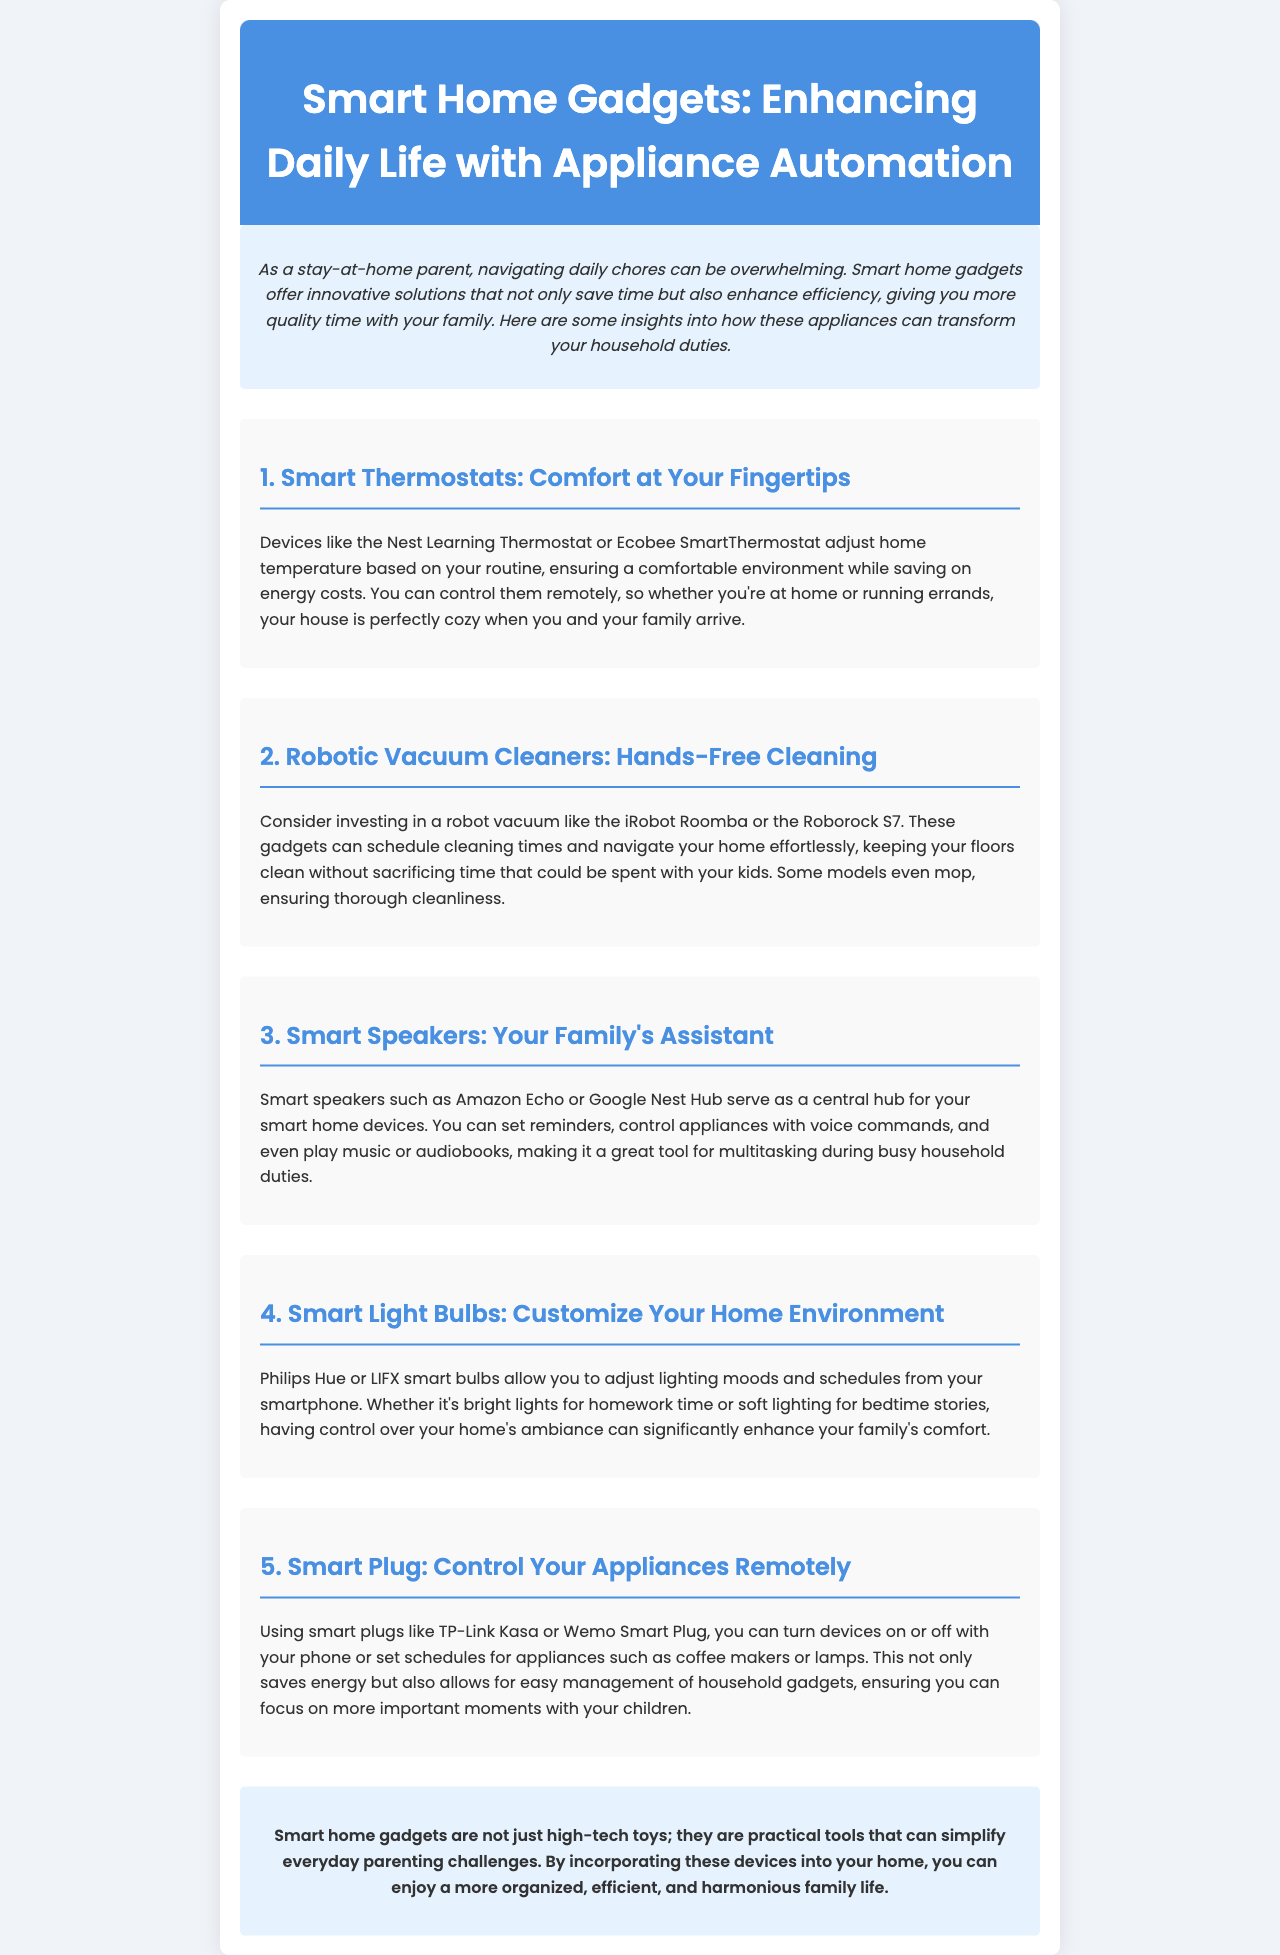what is the title of the newsletter? The title of the newsletter is presented prominently at the top of the document.
Answer: Smart Home Gadgets: Enhancing Daily Life with Appliance Automation what is a benefit of smart thermostats? The document states that smart thermostats adjust home temperature according to routine, helping to save energy costs.
Answer: Saving on energy costs which smart vacuum brands are mentioned? The newsletter lists specific brands that provide robotic vacuum cleaners.
Answer: iRobot Roomba or Roborock S7 what can smart speakers do? The document elaborates on the functions of smart speakers, stating their roles in a smart home.
Answer: Set reminders and control appliances how can smart light bulbs enhance family comfort? The document explains how smart light bulbs allow adjustment of lighting for different moods, impacting family ambiance.
Answer: Customize lighting moods what purpose do smart plugs serve? The newsletter describes the function of smart plugs in managing household devices and schedules.
Answer: Control appliances remotely what type of gadgets enhance daily chores? The introduction indicates that smart home gadgets specifically improve household chores and efficiency.
Answer: Smart home gadgets which section discusses hands-free cleaning? This section specifically focuses on a type of smart device highlighted for its cleaning capabilities.
Answer: Robotic Vacuum Cleaners 